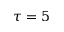<formula> <loc_0><loc_0><loc_500><loc_500>\tau = 5</formula> 